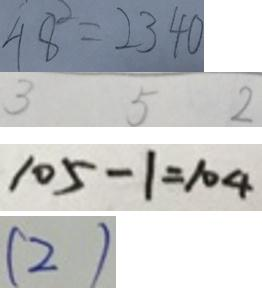<formula> <loc_0><loc_0><loc_500><loc_500>4 8 ^ { 2 } = 2 3 4 0 
 3 5 2 
 1 0 5 - 1 = 1 0 4 
 ( 2 )</formula> 